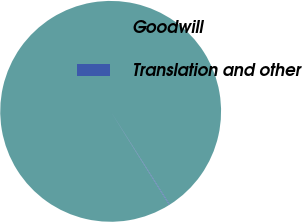Convert chart to OTSL. <chart><loc_0><loc_0><loc_500><loc_500><pie_chart><fcel>Goodwill<fcel>Translation and other<nl><fcel>99.91%<fcel>0.09%<nl></chart> 